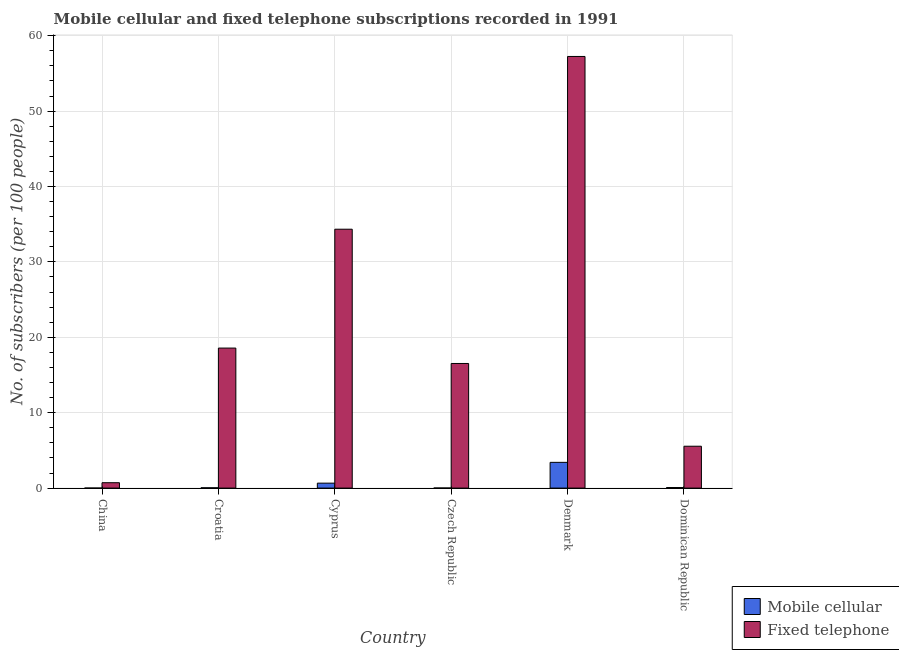How many different coloured bars are there?
Ensure brevity in your answer.  2. How many groups of bars are there?
Keep it short and to the point. 6. How many bars are there on the 3rd tick from the right?
Offer a terse response. 2. What is the label of the 6th group of bars from the left?
Your answer should be very brief. Dominican Republic. What is the number of mobile cellular subscribers in Czech Republic?
Provide a succinct answer. 0.01. Across all countries, what is the maximum number of mobile cellular subscribers?
Offer a terse response. 3.41. Across all countries, what is the minimum number of mobile cellular subscribers?
Give a very brief answer. 0. In which country was the number of fixed telephone subscribers maximum?
Your response must be concise. Denmark. In which country was the number of mobile cellular subscribers minimum?
Make the answer very short. China. What is the total number of mobile cellular subscribers in the graph?
Ensure brevity in your answer.  4.2. What is the difference between the number of fixed telephone subscribers in Cyprus and that in Denmark?
Make the answer very short. -22.91. What is the difference between the number of mobile cellular subscribers in Denmark and the number of fixed telephone subscribers in China?
Your answer should be very brief. 2.7. What is the average number of mobile cellular subscribers per country?
Your answer should be very brief. 0.7. What is the difference between the number of mobile cellular subscribers and number of fixed telephone subscribers in China?
Your answer should be compact. -0.71. What is the ratio of the number of mobile cellular subscribers in China to that in Czech Republic?
Your answer should be compact. 0.33. Is the difference between the number of fixed telephone subscribers in China and Cyprus greater than the difference between the number of mobile cellular subscribers in China and Cyprus?
Ensure brevity in your answer.  No. What is the difference between the highest and the second highest number of mobile cellular subscribers?
Your answer should be compact. 2.76. What is the difference between the highest and the lowest number of mobile cellular subscribers?
Ensure brevity in your answer.  3.41. In how many countries, is the number of fixed telephone subscribers greater than the average number of fixed telephone subscribers taken over all countries?
Ensure brevity in your answer.  2. What does the 1st bar from the left in Denmark represents?
Make the answer very short. Mobile cellular. What does the 1st bar from the right in Czech Republic represents?
Keep it short and to the point. Fixed telephone. How many bars are there?
Give a very brief answer. 12. What is the difference between two consecutive major ticks on the Y-axis?
Make the answer very short. 10. Are the values on the major ticks of Y-axis written in scientific E-notation?
Provide a succinct answer. No. Where does the legend appear in the graph?
Provide a short and direct response. Bottom right. What is the title of the graph?
Your answer should be compact. Mobile cellular and fixed telephone subscriptions recorded in 1991. What is the label or title of the Y-axis?
Your answer should be compact. No. of subscribers (per 100 people). What is the No. of subscribers (per 100 people) in Mobile cellular in China?
Your answer should be very brief. 0. What is the No. of subscribers (per 100 people) in Fixed telephone in China?
Make the answer very short. 0.71. What is the No. of subscribers (per 100 people) in Mobile cellular in Croatia?
Your answer should be very brief. 0.04. What is the No. of subscribers (per 100 people) of Fixed telephone in Croatia?
Give a very brief answer. 18.57. What is the No. of subscribers (per 100 people) of Mobile cellular in Cyprus?
Your response must be concise. 0.66. What is the No. of subscribers (per 100 people) of Fixed telephone in Cyprus?
Your response must be concise. 34.34. What is the No. of subscribers (per 100 people) in Mobile cellular in Czech Republic?
Offer a terse response. 0.01. What is the No. of subscribers (per 100 people) in Fixed telephone in Czech Republic?
Provide a short and direct response. 16.53. What is the No. of subscribers (per 100 people) of Mobile cellular in Denmark?
Ensure brevity in your answer.  3.41. What is the No. of subscribers (per 100 people) of Fixed telephone in Denmark?
Keep it short and to the point. 57.25. What is the No. of subscribers (per 100 people) in Mobile cellular in Dominican Republic?
Offer a very short reply. 0.08. What is the No. of subscribers (per 100 people) of Fixed telephone in Dominican Republic?
Keep it short and to the point. 5.55. Across all countries, what is the maximum No. of subscribers (per 100 people) of Mobile cellular?
Offer a very short reply. 3.41. Across all countries, what is the maximum No. of subscribers (per 100 people) in Fixed telephone?
Provide a succinct answer. 57.25. Across all countries, what is the minimum No. of subscribers (per 100 people) in Mobile cellular?
Your answer should be compact. 0. Across all countries, what is the minimum No. of subscribers (per 100 people) in Fixed telephone?
Keep it short and to the point. 0.71. What is the total No. of subscribers (per 100 people) of Mobile cellular in the graph?
Provide a short and direct response. 4.2. What is the total No. of subscribers (per 100 people) in Fixed telephone in the graph?
Keep it short and to the point. 132.95. What is the difference between the No. of subscribers (per 100 people) in Mobile cellular in China and that in Croatia?
Your answer should be compact. -0.04. What is the difference between the No. of subscribers (per 100 people) of Fixed telephone in China and that in Croatia?
Provide a succinct answer. -17.86. What is the difference between the No. of subscribers (per 100 people) of Mobile cellular in China and that in Cyprus?
Ensure brevity in your answer.  -0.65. What is the difference between the No. of subscribers (per 100 people) in Fixed telephone in China and that in Cyprus?
Your response must be concise. -33.62. What is the difference between the No. of subscribers (per 100 people) of Mobile cellular in China and that in Czech Republic?
Make the answer very short. -0.01. What is the difference between the No. of subscribers (per 100 people) of Fixed telephone in China and that in Czech Republic?
Provide a short and direct response. -15.81. What is the difference between the No. of subscribers (per 100 people) in Mobile cellular in China and that in Denmark?
Your answer should be compact. -3.41. What is the difference between the No. of subscribers (per 100 people) in Fixed telephone in China and that in Denmark?
Provide a succinct answer. -56.53. What is the difference between the No. of subscribers (per 100 people) of Mobile cellular in China and that in Dominican Republic?
Keep it short and to the point. -0.07. What is the difference between the No. of subscribers (per 100 people) in Fixed telephone in China and that in Dominican Republic?
Your response must be concise. -4.84. What is the difference between the No. of subscribers (per 100 people) of Mobile cellular in Croatia and that in Cyprus?
Ensure brevity in your answer.  -0.61. What is the difference between the No. of subscribers (per 100 people) of Fixed telephone in Croatia and that in Cyprus?
Offer a terse response. -15.77. What is the difference between the No. of subscribers (per 100 people) in Mobile cellular in Croatia and that in Czech Republic?
Your answer should be very brief. 0.03. What is the difference between the No. of subscribers (per 100 people) in Fixed telephone in Croatia and that in Czech Republic?
Make the answer very short. 2.04. What is the difference between the No. of subscribers (per 100 people) of Mobile cellular in Croatia and that in Denmark?
Your response must be concise. -3.37. What is the difference between the No. of subscribers (per 100 people) in Fixed telephone in Croatia and that in Denmark?
Your answer should be compact. -38.68. What is the difference between the No. of subscribers (per 100 people) of Mobile cellular in Croatia and that in Dominican Republic?
Keep it short and to the point. -0.03. What is the difference between the No. of subscribers (per 100 people) in Fixed telephone in Croatia and that in Dominican Republic?
Your answer should be very brief. 13.02. What is the difference between the No. of subscribers (per 100 people) of Mobile cellular in Cyprus and that in Czech Republic?
Your answer should be very brief. 0.64. What is the difference between the No. of subscribers (per 100 people) in Fixed telephone in Cyprus and that in Czech Republic?
Ensure brevity in your answer.  17.81. What is the difference between the No. of subscribers (per 100 people) of Mobile cellular in Cyprus and that in Denmark?
Provide a succinct answer. -2.76. What is the difference between the No. of subscribers (per 100 people) of Fixed telephone in Cyprus and that in Denmark?
Your answer should be very brief. -22.91. What is the difference between the No. of subscribers (per 100 people) of Mobile cellular in Cyprus and that in Dominican Republic?
Your answer should be very brief. 0.58. What is the difference between the No. of subscribers (per 100 people) of Fixed telephone in Cyprus and that in Dominican Republic?
Offer a very short reply. 28.78. What is the difference between the No. of subscribers (per 100 people) of Mobile cellular in Czech Republic and that in Denmark?
Your answer should be very brief. -3.4. What is the difference between the No. of subscribers (per 100 people) of Fixed telephone in Czech Republic and that in Denmark?
Keep it short and to the point. -40.72. What is the difference between the No. of subscribers (per 100 people) in Mobile cellular in Czech Republic and that in Dominican Republic?
Your response must be concise. -0.06. What is the difference between the No. of subscribers (per 100 people) in Fixed telephone in Czech Republic and that in Dominican Republic?
Provide a succinct answer. 10.97. What is the difference between the No. of subscribers (per 100 people) of Mobile cellular in Denmark and that in Dominican Republic?
Ensure brevity in your answer.  3.34. What is the difference between the No. of subscribers (per 100 people) of Fixed telephone in Denmark and that in Dominican Republic?
Give a very brief answer. 51.69. What is the difference between the No. of subscribers (per 100 people) in Mobile cellular in China and the No. of subscribers (per 100 people) in Fixed telephone in Croatia?
Make the answer very short. -18.57. What is the difference between the No. of subscribers (per 100 people) in Mobile cellular in China and the No. of subscribers (per 100 people) in Fixed telephone in Cyprus?
Keep it short and to the point. -34.33. What is the difference between the No. of subscribers (per 100 people) of Mobile cellular in China and the No. of subscribers (per 100 people) of Fixed telephone in Czech Republic?
Your response must be concise. -16.52. What is the difference between the No. of subscribers (per 100 people) of Mobile cellular in China and the No. of subscribers (per 100 people) of Fixed telephone in Denmark?
Give a very brief answer. -57.24. What is the difference between the No. of subscribers (per 100 people) of Mobile cellular in China and the No. of subscribers (per 100 people) of Fixed telephone in Dominican Republic?
Ensure brevity in your answer.  -5.55. What is the difference between the No. of subscribers (per 100 people) of Mobile cellular in Croatia and the No. of subscribers (per 100 people) of Fixed telephone in Cyprus?
Offer a terse response. -34.29. What is the difference between the No. of subscribers (per 100 people) in Mobile cellular in Croatia and the No. of subscribers (per 100 people) in Fixed telephone in Czech Republic?
Make the answer very short. -16.49. What is the difference between the No. of subscribers (per 100 people) in Mobile cellular in Croatia and the No. of subscribers (per 100 people) in Fixed telephone in Denmark?
Your answer should be very brief. -57.21. What is the difference between the No. of subscribers (per 100 people) of Mobile cellular in Croatia and the No. of subscribers (per 100 people) of Fixed telephone in Dominican Republic?
Keep it short and to the point. -5.51. What is the difference between the No. of subscribers (per 100 people) in Mobile cellular in Cyprus and the No. of subscribers (per 100 people) in Fixed telephone in Czech Republic?
Keep it short and to the point. -15.87. What is the difference between the No. of subscribers (per 100 people) of Mobile cellular in Cyprus and the No. of subscribers (per 100 people) of Fixed telephone in Denmark?
Provide a succinct answer. -56.59. What is the difference between the No. of subscribers (per 100 people) of Mobile cellular in Cyprus and the No. of subscribers (per 100 people) of Fixed telephone in Dominican Republic?
Provide a short and direct response. -4.9. What is the difference between the No. of subscribers (per 100 people) in Mobile cellular in Czech Republic and the No. of subscribers (per 100 people) in Fixed telephone in Denmark?
Give a very brief answer. -57.24. What is the difference between the No. of subscribers (per 100 people) of Mobile cellular in Czech Republic and the No. of subscribers (per 100 people) of Fixed telephone in Dominican Republic?
Your answer should be very brief. -5.54. What is the difference between the No. of subscribers (per 100 people) of Mobile cellular in Denmark and the No. of subscribers (per 100 people) of Fixed telephone in Dominican Republic?
Offer a terse response. -2.14. What is the average No. of subscribers (per 100 people) in Mobile cellular per country?
Offer a very short reply. 0.7. What is the average No. of subscribers (per 100 people) of Fixed telephone per country?
Provide a succinct answer. 22.16. What is the difference between the No. of subscribers (per 100 people) of Mobile cellular and No. of subscribers (per 100 people) of Fixed telephone in China?
Your response must be concise. -0.71. What is the difference between the No. of subscribers (per 100 people) in Mobile cellular and No. of subscribers (per 100 people) in Fixed telephone in Croatia?
Your answer should be very brief. -18.53. What is the difference between the No. of subscribers (per 100 people) of Mobile cellular and No. of subscribers (per 100 people) of Fixed telephone in Cyprus?
Keep it short and to the point. -33.68. What is the difference between the No. of subscribers (per 100 people) of Mobile cellular and No. of subscribers (per 100 people) of Fixed telephone in Czech Republic?
Your answer should be compact. -16.52. What is the difference between the No. of subscribers (per 100 people) in Mobile cellular and No. of subscribers (per 100 people) in Fixed telephone in Denmark?
Your answer should be very brief. -53.83. What is the difference between the No. of subscribers (per 100 people) of Mobile cellular and No. of subscribers (per 100 people) of Fixed telephone in Dominican Republic?
Keep it short and to the point. -5.48. What is the ratio of the No. of subscribers (per 100 people) of Mobile cellular in China to that in Croatia?
Make the answer very short. 0.1. What is the ratio of the No. of subscribers (per 100 people) of Fixed telephone in China to that in Croatia?
Your answer should be compact. 0.04. What is the ratio of the No. of subscribers (per 100 people) of Mobile cellular in China to that in Cyprus?
Your answer should be compact. 0.01. What is the ratio of the No. of subscribers (per 100 people) in Fixed telephone in China to that in Cyprus?
Provide a succinct answer. 0.02. What is the ratio of the No. of subscribers (per 100 people) in Mobile cellular in China to that in Czech Republic?
Your answer should be compact. 0.33. What is the ratio of the No. of subscribers (per 100 people) in Fixed telephone in China to that in Czech Republic?
Keep it short and to the point. 0.04. What is the ratio of the No. of subscribers (per 100 people) in Mobile cellular in China to that in Denmark?
Offer a very short reply. 0. What is the ratio of the No. of subscribers (per 100 people) of Fixed telephone in China to that in Denmark?
Give a very brief answer. 0.01. What is the ratio of the No. of subscribers (per 100 people) in Mobile cellular in China to that in Dominican Republic?
Your answer should be compact. 0.05. What is the ratio of the No. of subscribers (per 100 people) of Fixed telephone in China to that in Dominican Republic?
Provide a short and direct response. 0.13. What is the ratio of the No. of subscribers (per 100 people) of Mobile cellular in Croatia to that in Cyprus?
Provide a short and direct response. 0.06. What is the ratio of the No. of subscribers (per 100 people) of Fixed telephone in Croatia to that in Cyprus?
Provide a succinct answer. 0.54. What is the ratio of the No. of subscribers (per 100 people) in Mobile cellular in Croatia to that in Czech Republic?
Offer a terse response. 3.5. What is the ratio of the No. of subscribers (per 100 people) of Fixed telephone in Croatia to that in Czech Republic?
Give a very brief answer. 1.12. What is the ratio of the No. of subscribers (per 100 people) of Mobile cellular in Croatia to that in Denmark?
Provide a short and direct response. 0.01. What is the ratio of the No. of subscribers (per 100 people) of Fixed telephone in Croatia to that in Denmark?
Your response must be concise. 0.32. What is the ratio of the No. of subscribers (per 100 people) of Mobile cellular in Croatia to that in Dominican Republic?
Your answer should be very brief. 0.55. What is the ratio of the No. of subscribers (per 100 people) of Fixed telephone in Croatia to that in Dominican Republic?
Offer a very short reply. 3.34. What is the ratio of the No. of subscribers (per 100 people) in Mobile cellular in Cyprus to that in Czech Republic?
Ensure brevity in your answer.  54.49. What is the ratio of the No. of subscribers (per 100 people) in Fixed telephone in Cyprus to that in Czech Republic?
Offer a very short reply. 2.08. What is the ratio of the No. of subscribers (per 100 people) of Mobile cellular in Cyprus to that in Denmark?
Your response must be concise. 0.19. What is the ratio of the No. of subscribers (per 100 people) in Fixed telephone in Cyprus to that in Denmark?
Make the answer very short. 0.6. What is the ratio of the No. of subscribers (per 100 people) of Mobile cellular in Cyprus to that in Dominican Republic?
Offer a very short reply. 8.64. What is the ratio of the No. of subscribers (per 100 people) in Fixed telephone in Cyprus to that in Dominican Republic?
Your answer should be compact. 6.18. What is the ratio of the No. of subscribers (per 100 people) of Mobile cellular in Czech Republic to that in Denmark?
Provide a short and direct response. 0. What is the ratio of the No. of subscribers (per 100 people) of Fixed telephone in Czech Republic to that in Denmark?
Your response must be concise. 0.29. What is the ratio of the No. of subscribers (per 100 people) of Mobile cellular in Czech Republic to that in Dominican Republic?
Ensure brevity in your answer.  0.16. What is the ratio of the No. of subscribers (per 100 people) in Fixed telephone in Czech Republic to that in Dominican Republic?
Offer a terse response. 2.98. What is the ratio of the No. of subscribers (per 100 people) in Mobile cellular in Denmark to that in Dominican Republic?
Provide a succinct answer. 45.02. What is the ratio of the No. of subscribers (per 100 people) of Fixed telephone in Denmark to that in Dominican Republic?
Your answer should be compact. 10.31. What is the difference between the highest and the second highest No. of subscribers (per 100 people) of Mobile cellular?
Make the answer very short. 2.76. What is the difference between the highest and the second highest No. of subscribers (per 100 people) of Fixed telephone?
Provide a succinct answer. 22.91. What is the difference between the highest and the lowest No. of subscribers (per 100 people) of Mobile cellular?
Your answer should be very brief. 3.41. What is the difference between the highest and the lowest No. of subscribers (per 100 people) in Fixed telephone?
Make the answer very short. 56.53. 